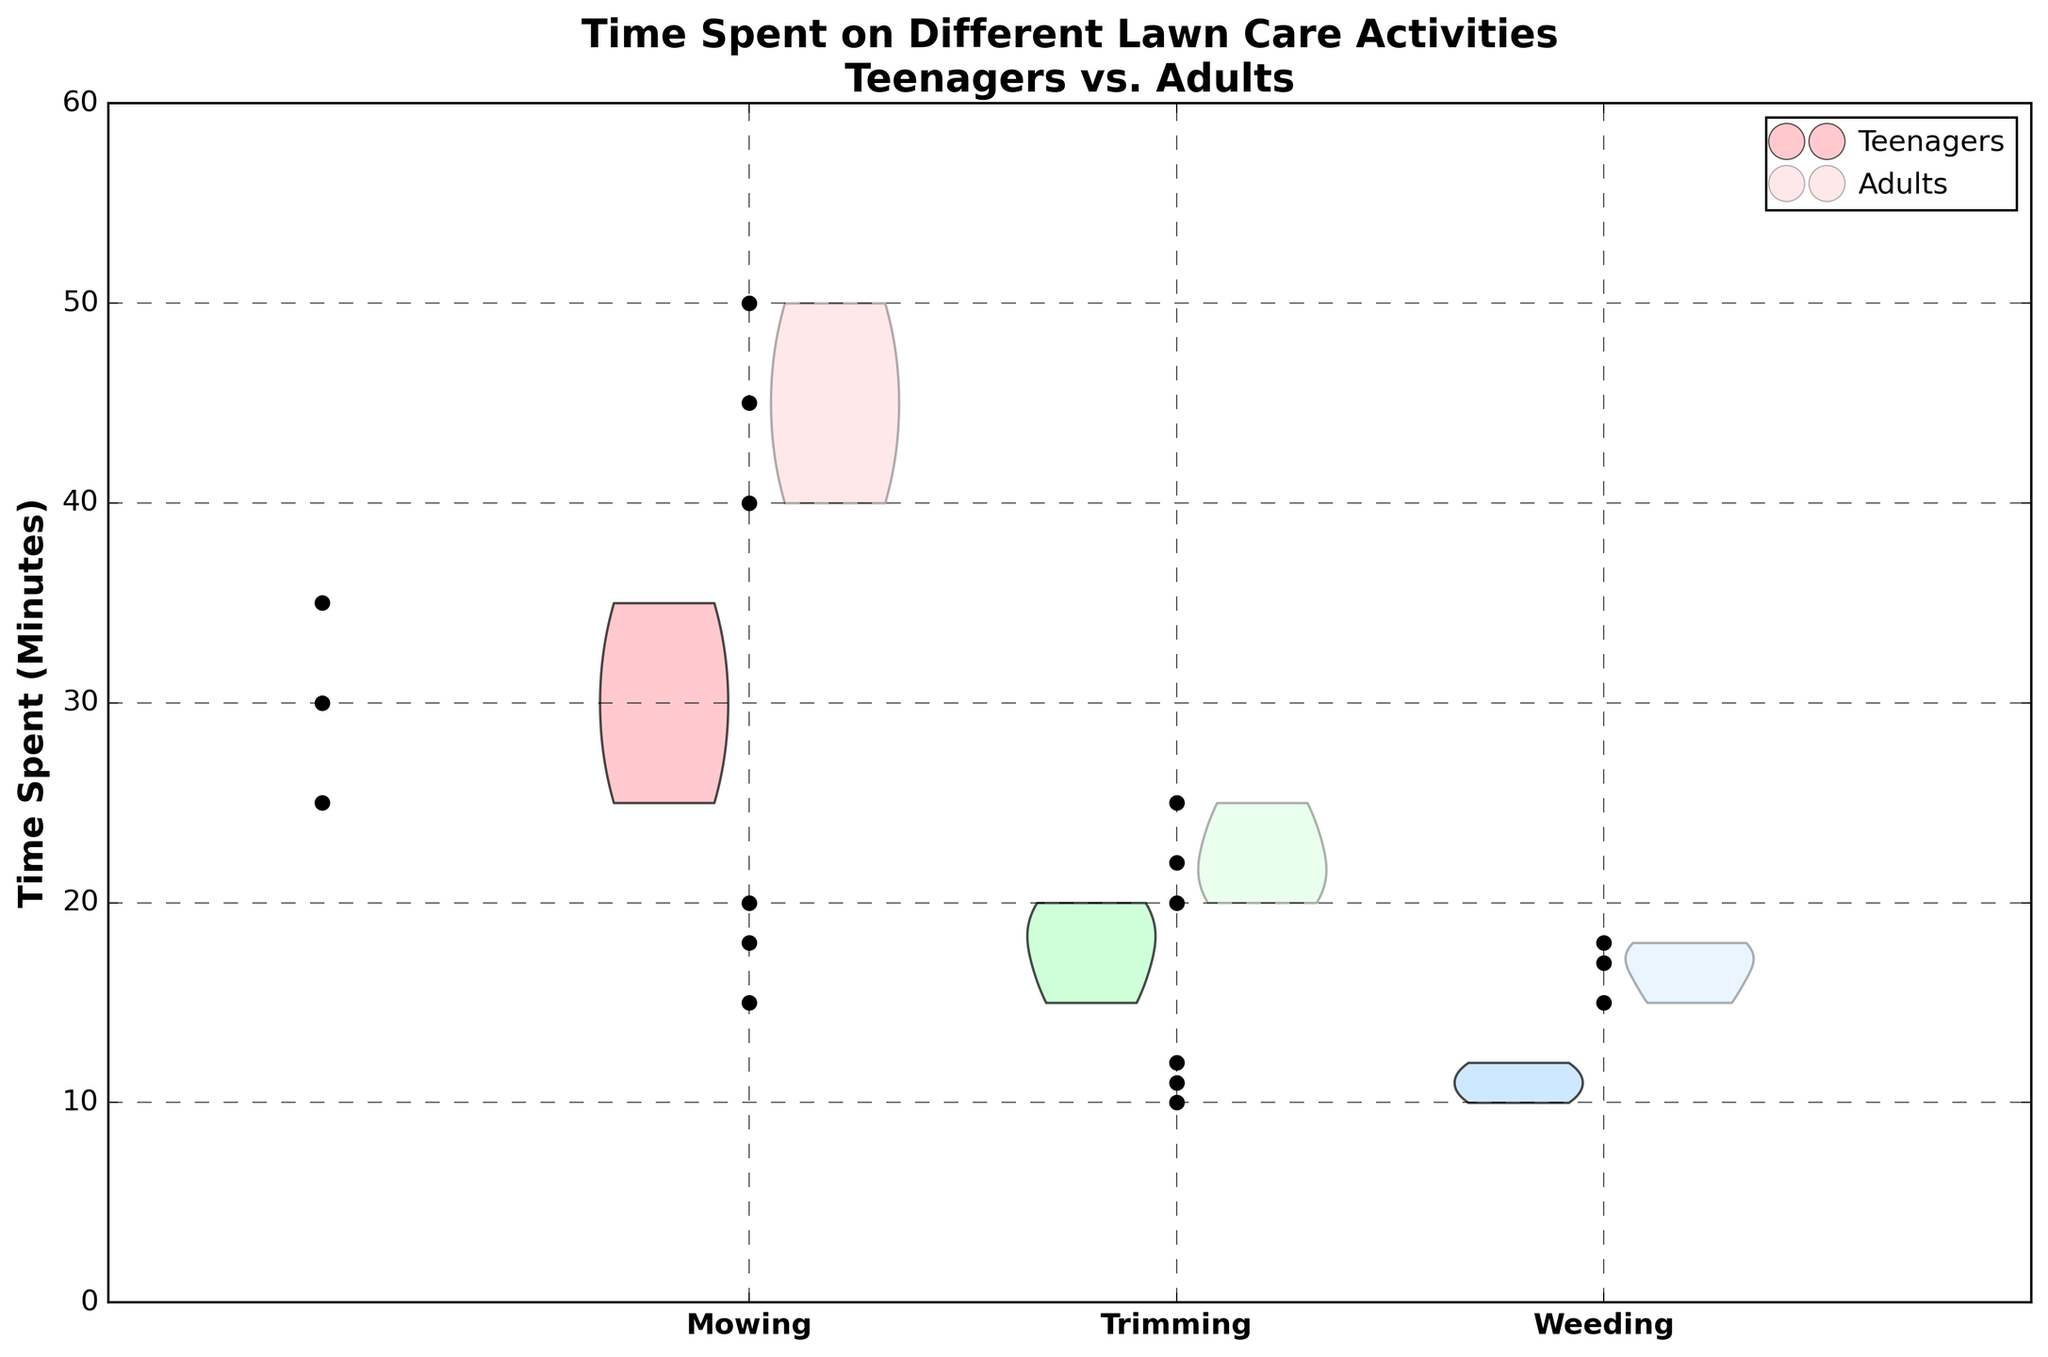How many different activities are shown in the figure? The figure shows three distinct activities on the x-axis: Mowing, Trimming, and Weeding.
Answer: 3 What are the colors representing Teenagers and Adults in the figure? The Teenagers' data is represented by brighter, more opaque colors, while the Adults' data is represented by lighter, more transparent colors.
Answer: Bright and opaque for Teenagers, light and transparent for Adults Which activity takes the longest time for both Teenagers and Adults? By observing the range of the violin plots, Mowing has the highest values for both Teenagers (20–40 minutes) and Adults (40–50 minutes).
Answer: Mowing How do the time spent on Trimming compare between Teenagers and Adults? The violin plot for Teenagers shows the range for Trimming is about 15–20 minutes, while for Adults it's approximately 20–25 minutes.
Answer: Adults spend more time on Trimming What is the average time spent on Weeding by Adults? The data points for Adults' Weeding times are 15, 17, and 18 minutes. The average is calculated as (15+17+18)/3.
Answer: 16.7 minutes Which activity has the least difference in time spent between Teenagers and Adults? For Weeding, the time difference is the smallest since both groups have values that are close (Teenagers: 10–12 minutes, Adults: 15–18 minutes).
Answer: Weeding Are the distributions of time spent on Mowing by Teenagers and Adults overlapping? Yes, by comparing the violin plots for Mowing, the ranges overlap between 30–35 minutes.
Answer: Yes Which AgeGroup has a wider spread in time spent on Mowing? The Adults' violin plot for Mowing has a wider spread (40–50 minutes) compared to Teenagers (25–35 minutes).
Answer: Adults What can you infer about the effort distribution in Trimming between Teenagers vs. Adults? The Teenagers' effort is more concentrated around 15–20 minutes, while Adults' efforts are clustered around 20–25 minutes.
Answer: Teens concentrate on 15–20 minutes; Adults on 20–25 minutes Do the Teens spend more consistent time across different activities compared to Adults? Teenagers' violin plots show similar widths for all activities indicating more consistent time, whereas Adults show more variation in Mowing.
Answer: Yes 